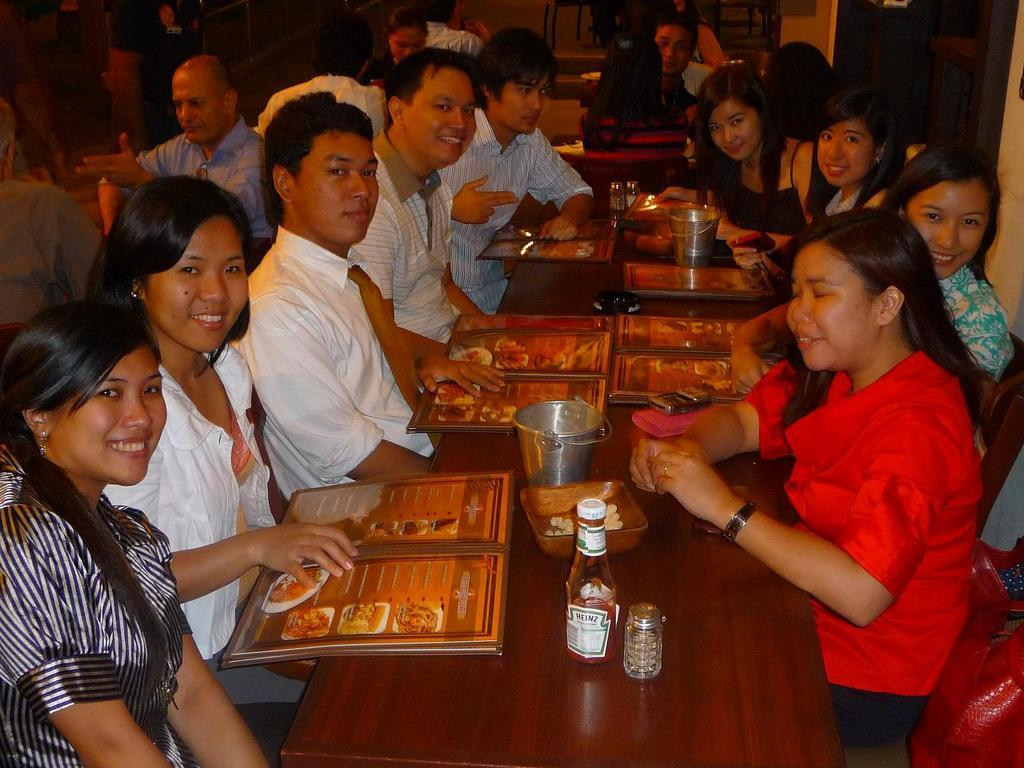What are the people in the image doing? The people in the image are sitting around a table. What is on the table that might be used for making decisions about food? The table contains a menu. What is on the table that might be used for drinking? The table contains a bottle. What is on the table that might be used for holding ice or cold items? The table contains a bucket. What is on the table that might be used for holding condiments or other items? The table contains a container. What type of celery can be seen growing in the background of the image? There is no celery visible in the image; it is focused on people sitting around a table with various items on it. 